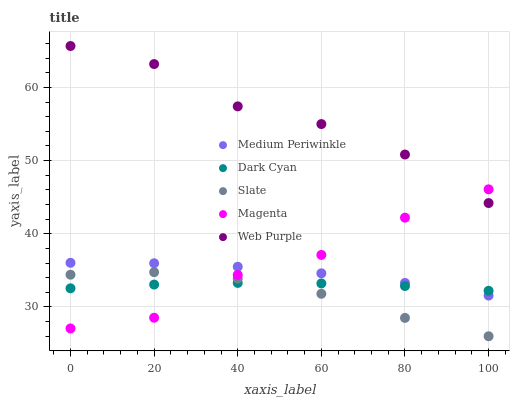Does Slate have the minimum area under the curve?
Answer yes or no. Yes. Does Web Purple have the maximum area under the curve?
Answer yes or no. Yes. Does Web Purple have the minimum area under the curve?
Answer yes or no. No. Does Slate have the maximum area under the curve?
Answer yes or no. No. Is Dark Cyan the smoothest?
Answer yes or no. Yes. Is Magenta the roughest?
Answer yes or no. Yes. Is Web Purple the smoothest?
Answer yes or no. No. Is Web Purple the roughest?
Answer yes or no. No. Does Slate have the lowest value?
Answer yes or no. Yes. Does Web Purple have the lowest value?
Answer yes or no. No. Does Web Purple have the highest value?
Answer yes or no. Yes. Does Slate have the highest value?
Answer yes or no. No. Is Slate less than Medium Periwinkle?
Answer yes or no. Yes. Is Medium Periwinkle greater than Slate?
Answer yes or no. Yes. Does Magenta intersect Slate?
Answer yes or no. Yes. Is Magenta less than Slate?
Answer yes or no. No. Is Magenta greater than Slate?
Answer yes or no. No. Does Slate intersect Medium Periwinkle?
Answer yes or no. No. 